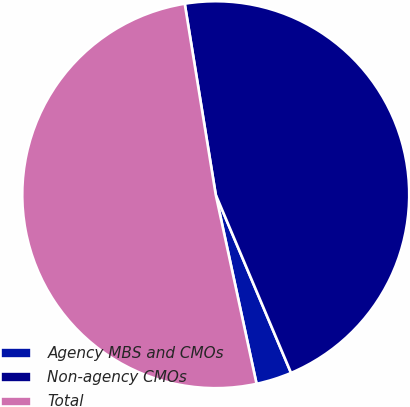Convert chart. <chart><loc_0><loc_0><loc_500><loc_500><pie_chart><fcel>Agency MBS and CMOs<fcel>Non-agency CMOs<fcel>Total<nl><fcel>2.98%<fcel>46.2%<fcel>50.82%<nl></chart> 